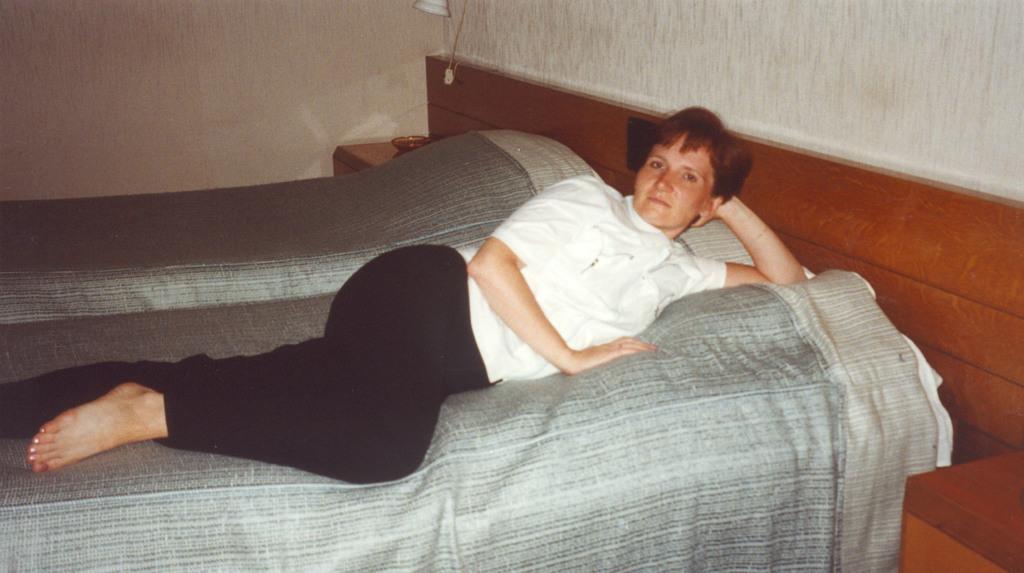Please provide a concise description of this image. a person is slaying on the bed. she is wearing a white t shirt and a black pant. the bed sheet is grey in color. behind the bed there are walls and a lamp is attached to the wall. 